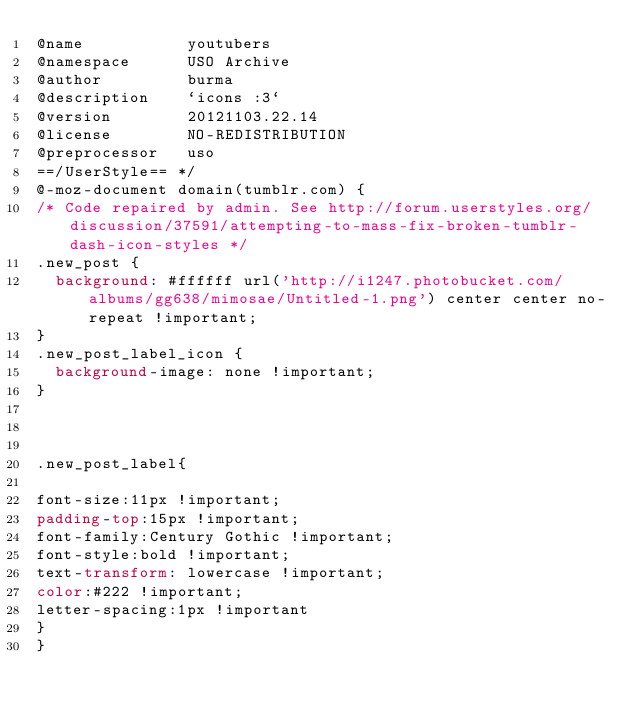<code> <loc_0><loc_0><loc_500><loc_500><_CSS_>@name           youtubers
@namespace      USO Archive
@author         burma
@description    `icons :3`
@version        20121103.22.14
@license        NO-REDISTRIBUTION
@preprocessor   uso
==/UserStyle== */
@-moz-document domain(tumblr.com) {
/* Code repaired by admin. See http://forum.userstyles.org/discussion/37591/attempting-to-mass-fix-broken-tumblr-dash-icon-styles */
.new_post {
	background: #ffffff url('http://i1247.photobucket.com/albums/gg638/mimosae/Untitled-1.png') center center no-repeat !important;
}
.new_post_label_icon {
	background-image: none !important;
}



.new_post_label{

font-size:11px !important;
padding-top:15px !important;
font-family:Century Gothic !important;
font-style:bold !important;
text-transform: lowercase !important;
color:#222 !important;
letter-spacing:1px !important
}
}</code> 